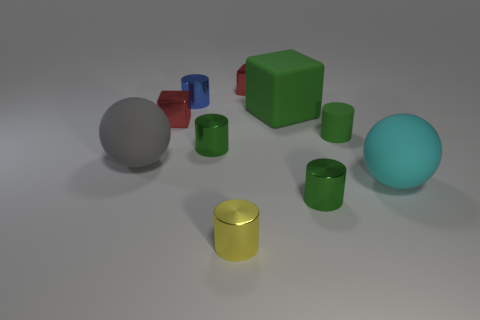How many green cylinders must be subtracted to get 2 green cylinders? 1 Subtract all large matte blocks. How many blocks are left? 2 Subtract 1 cylinders. How many cylinders are left? 4 Subtract all green balls. Subtract all purple cylinders. How many balls are left? 2 Subtract all yellow balls. How many yellow cylinders are left? 1 Subtract all big gray metal spheres. Subtract all green cubes. How many objects are left? 9 Add 5 big green matte blocks. How many big green matte blocks are left? 6 Add 6 tiny red rubber things. How many tiny red rubber things exist? 6 Subtract all green blocks. How many blocks are left? 2 Subtract 0 gray cylinders. How many objects are left? 10 